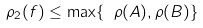<formula> <loc_0><loc_0><loc_500><loc_500>\rho _ { 2 } ( f ) \leq \max \{ \ \rho ( A ) , \rho ( B ) \} \</formula> 